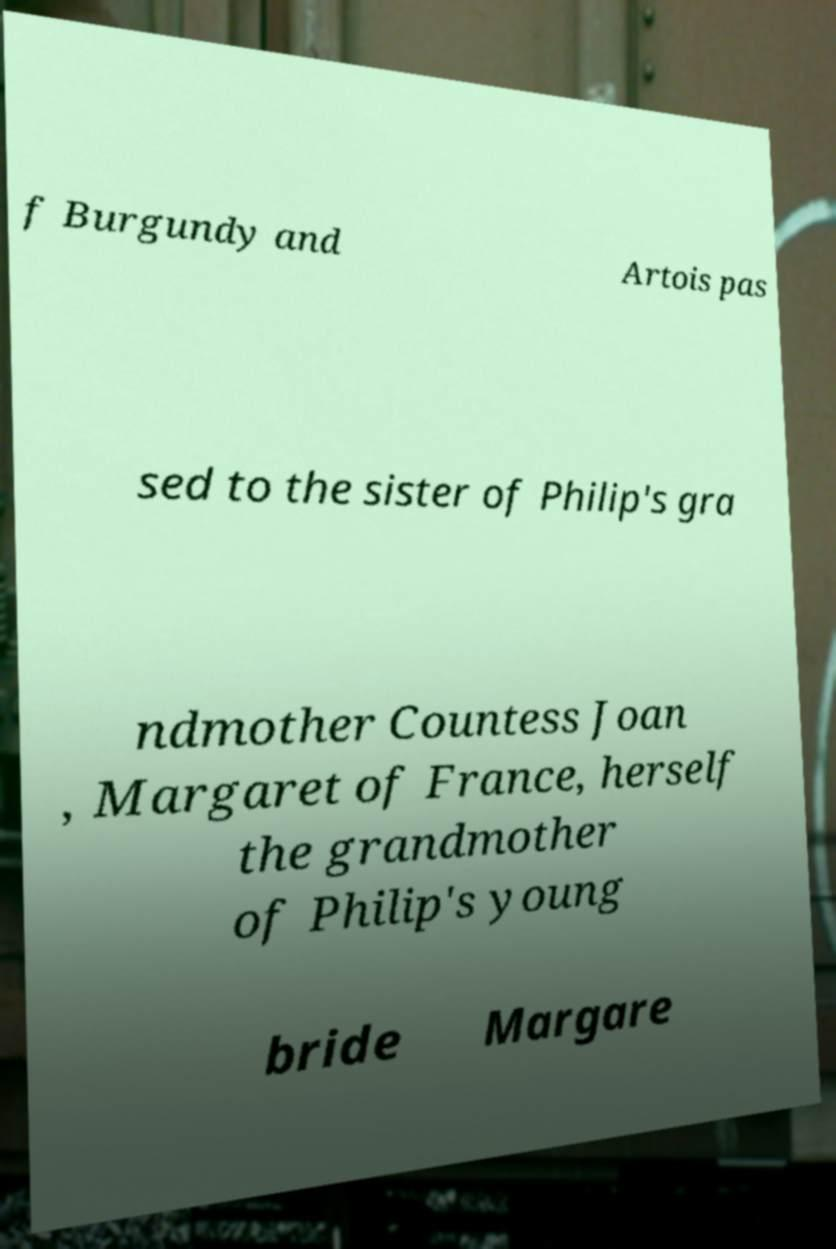For documentation purposes, I need the text within this image transcribed. Could you provide that? f Burgundy and Artois pas sed to the sister of Philip's gra ndmother Countess Joan , Margaret of France, herself the grandmother of Philip's young bride Margare 